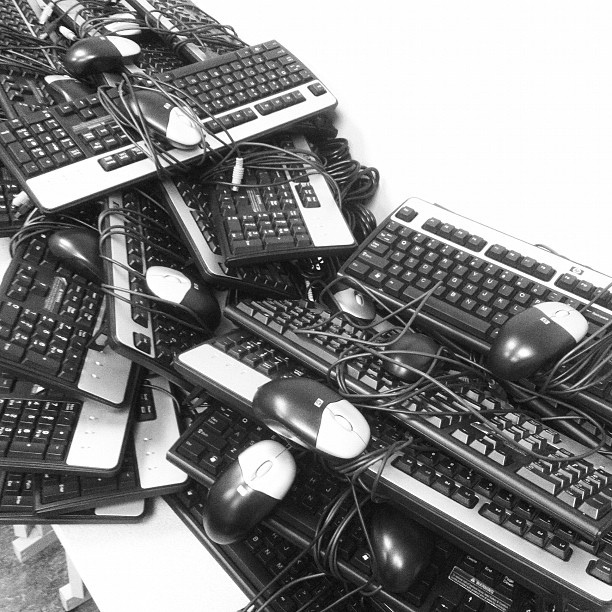Read all the text in this image. L 